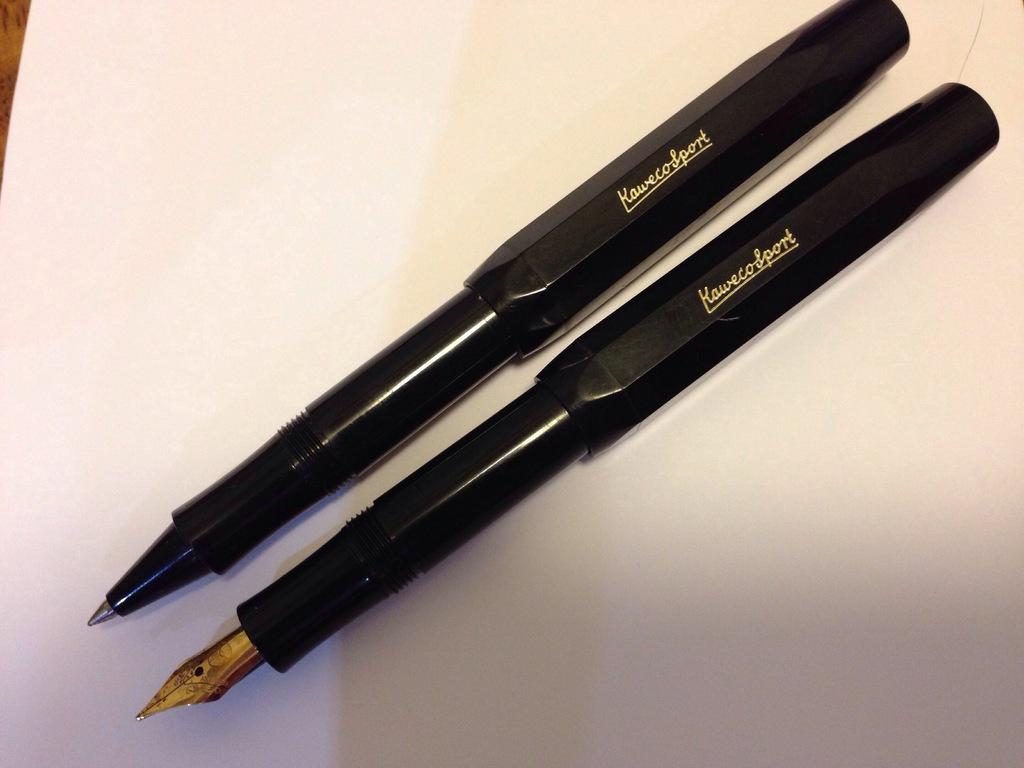What objects are present in the image? There are two pens in the image. What is the pens placed on? The pens are on a paper. Where are the pens located in the image? The pens are in the center of the image. What type of love can be seen expressed between the ants in the image? There are no ants present in the image, and therefore no love can be observed between them. What type of shirt is the pen wearing in the image? The pens are inanimate objects and do not wear clothing, such as a shirt. 